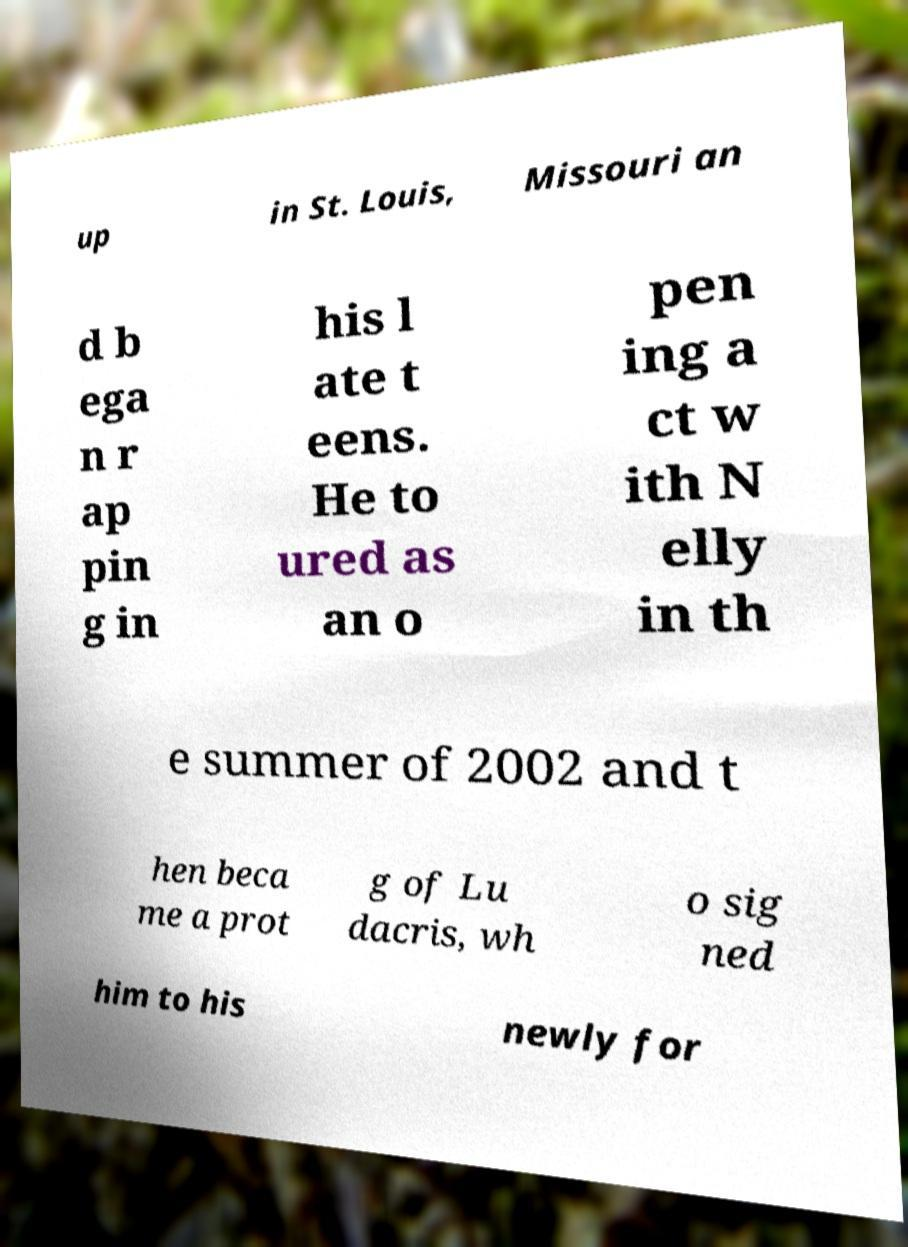Can you read and provide the text displayed in the image?This photo seems to have some interesting text. Can you extract and type it out for me? up in St. Louis, Missouri an d b ega n r ap pin g in his l ate t eens. He to ured as an o pen ing a ct w ith N elly in th e summer of 2002 and t hen beca me a prot g of Lu dacris, wh o sig ned him to his newly for 